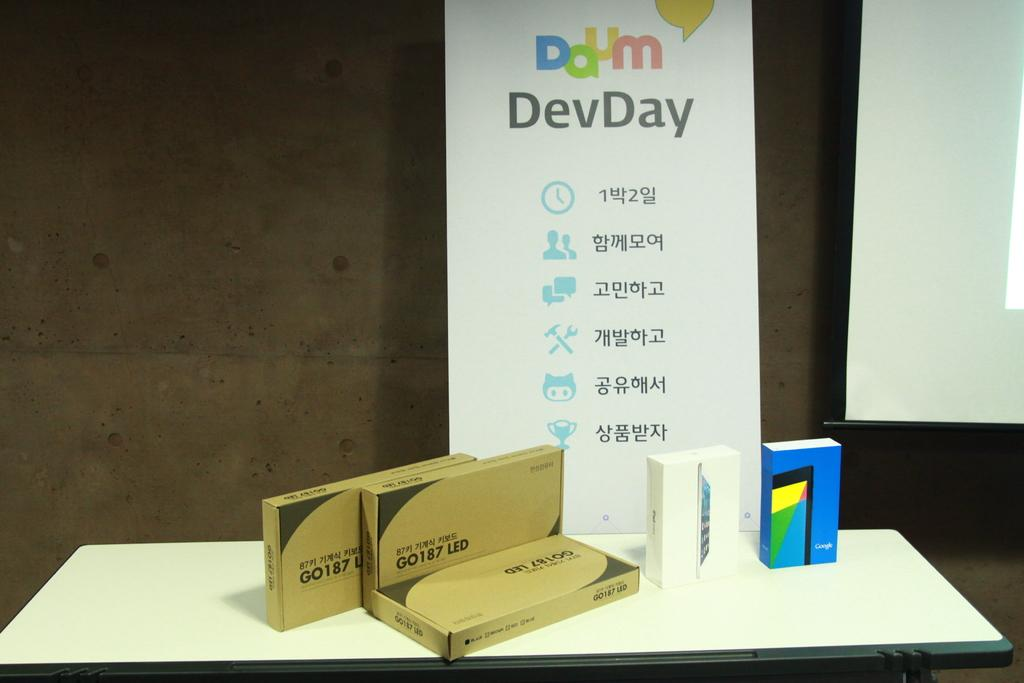<image>
Describe the image concisely. Boxes sit on a table infront of a sign saying ddum DevDay. 